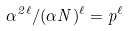Convert formula to latex. <formula><loc_0><loc_0><loc_500><loc_500>\alpha ^ { 2 \ell } / ( \alpha N ) ^ { \ell } = p ^ { \ell }</formula> 